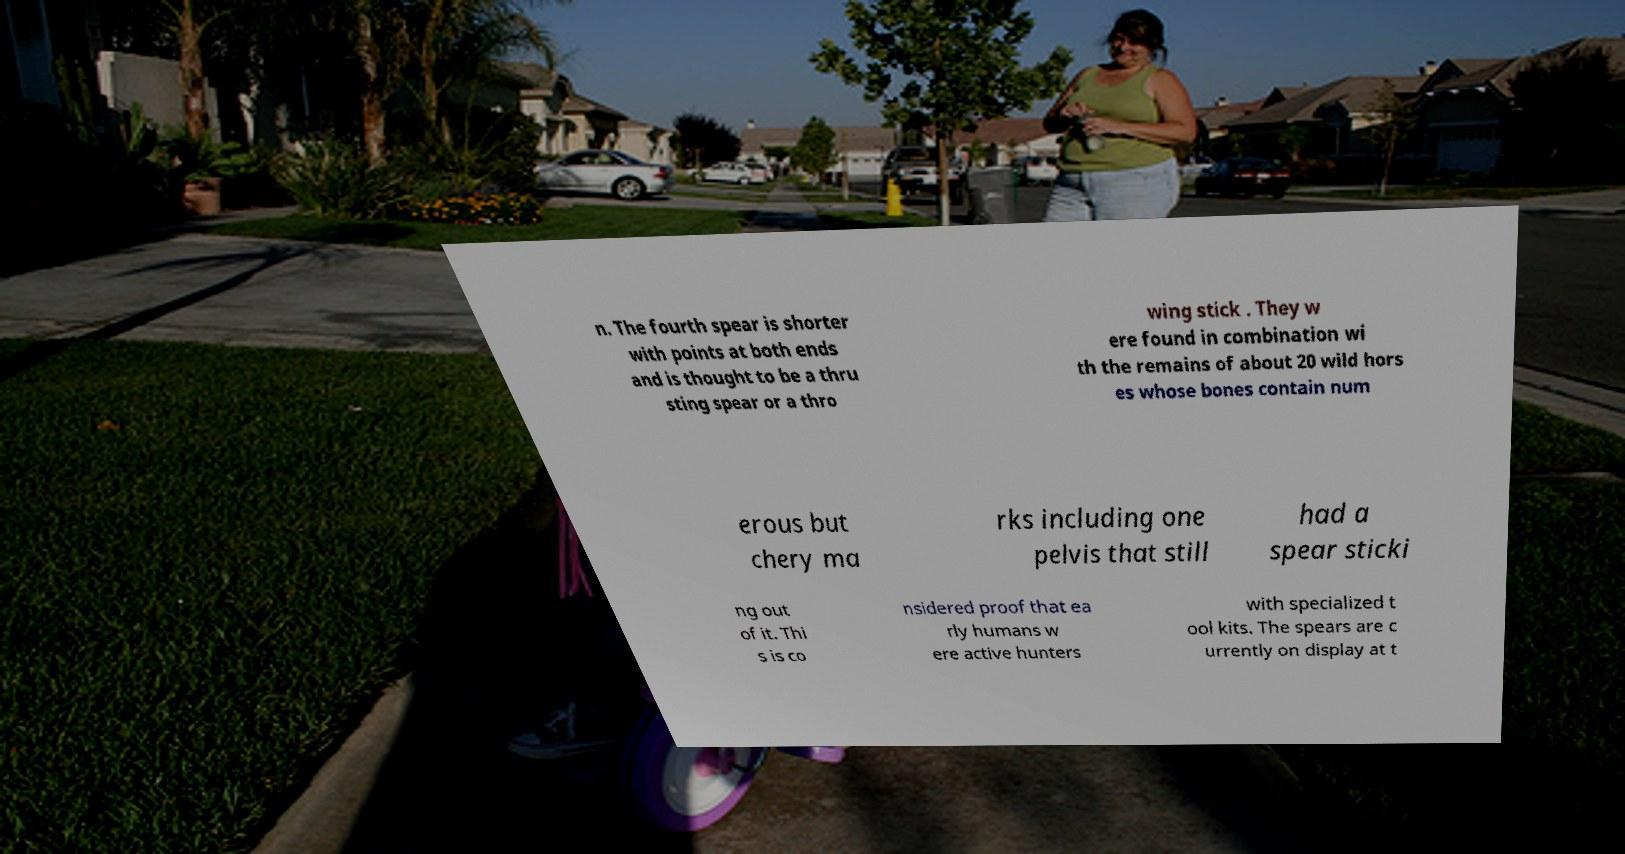Could you extract and type out the text from this image? n. The fourth spear is shorter with points at both ends and is thought to be a thru sting spear or a thro wing stick . They w ere found in combination wi th the remains of about 20 wild hors es whose bones contain num erous but chery ma rks including one pelvis that still had a spear sticki ng out of it. Thi s is co nsidered proof that ea rly humans w ere active hunters with specialized t ool kits. The spears are c urrently on display at t 